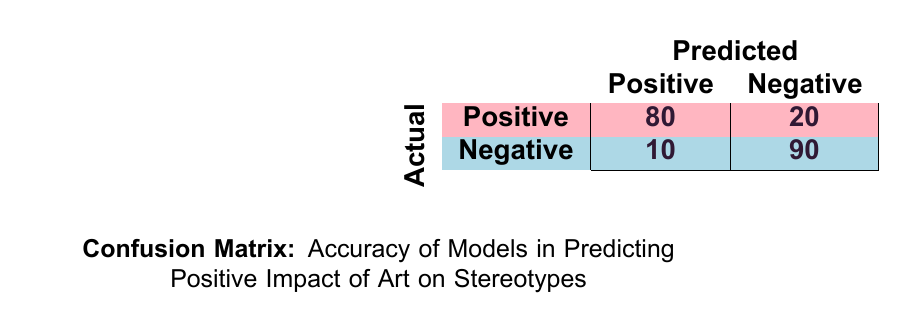What is the number of actual positive artworks that were predicted as positive? From the confusion matrix, under the "Actual Positive" category, the number of artworks that were predicted as positive is directly noted as 80.
Answer: 80 What is the number of actual negative artworks that were predicted as negative? From the confusion matrix, under the "Actual Negative" category, the number of artworks that were predicted as negative is given as 90.
Answer: 90 How many artworks were classified incorrectly as positive (false positives)? Looking at the confusion matrix, the number of actual negatives that were incorrectly predicted as positive is the value of 10.
Answer: 10 What is the total number of artworks that had a positive predicted impact? To find this, we sum both the predicted positive artworks from actual positives (80) and actual negatives (10). So, 80 + 10 equals 90 artworks predicted as positive.
Answer: 90 What is the accuracy of the model in predicting the positive impact of art on stereotypes? Accuracy is calculated by dividing the sum of true positives (80) and true negatives (90) by the total number of predictions (80 + 20 + 10 + 90). Thus, (80 + 90) / 200 = 170 / 200, which simplifies to 0.85 or 85%.
Answer: 85% Are there any artworks predicted as negative that actually have a positive impact? Referring to the confusion matrix, there is 1 artwork that was predicted as negative but is actually positive, which corresponds to the value of 20.
Answer: Yes How many actual positive artworks were incorrectly predicted as negative? In the confusion matrix, it shows that 20 actual positive artworks were incorrectly predicted as negative, as stated in the first row.
Answer: 20 What is the total number of artworks that are actually empowering? To find this total, we add the number of artworks identified as actual positive (80) to the number of artworks actually identified as negative but empowered (0). It is evident that there are no artworks that fall into the negative empowering category, so the total remains as 80.
Answer: 80 What percentage of actual positive artworks were correctly predicted as positive? To find this percentage, divide the number of correctly predicted positives (80) by the total actual positives (80 + 20) and multiply by 100. Therefore, (80 / 100) * 100 = 80%.
Answer: 80% 